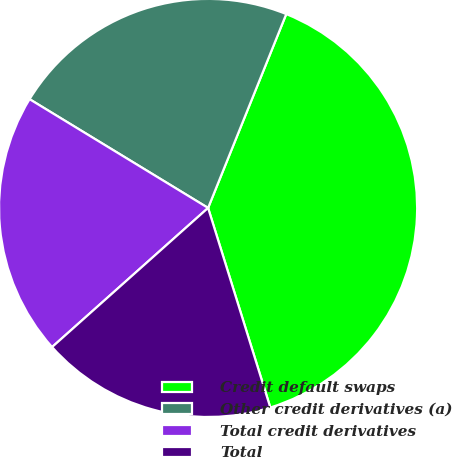Convert chart to OTSL. <chart><loc_0><loc_0><loc_500><loc_500><pie_chart><fcel>Credit default swaps<fcel>Other credit derivatives (a)<fcel>Total credit derivatives<fcel>Total<nl><fcel>39.09%<fcel>22.39%<fcel>20.3%<fcel>18.22%<nl></chart> 